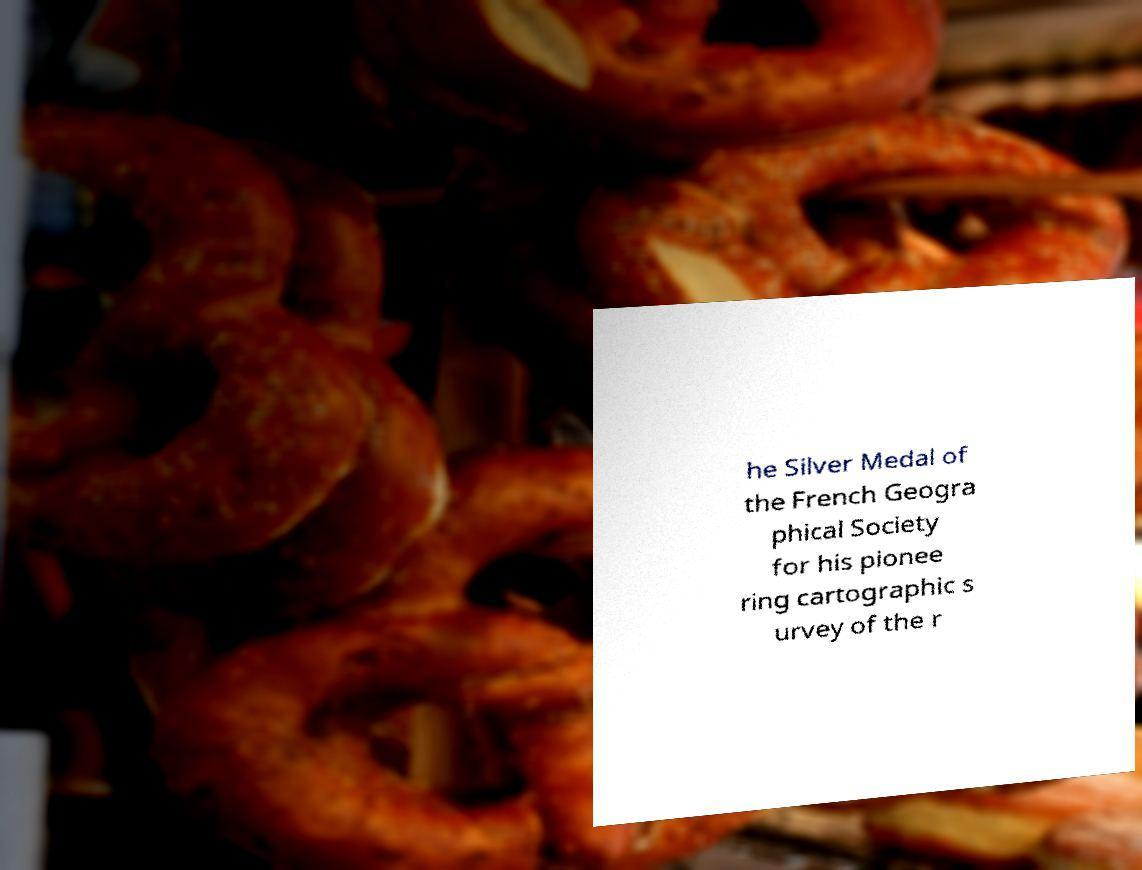Please identify and transcribe the text found in this image. he Silver Medal of the French Geogra phical Society for his pionee ring cartographic s urvey of the r 